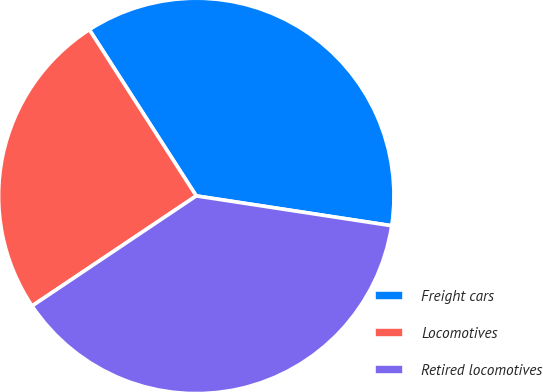Convert chart. <chart><loc_0><loc_0><loc_500><loc_500><pie_chart><fcel>Freight cars<fcel>Locomotives<fcel>Retired locomotives<nl><fcel>36.51%<fcel>25.3%<fcel>38.19%<nl></chart> 